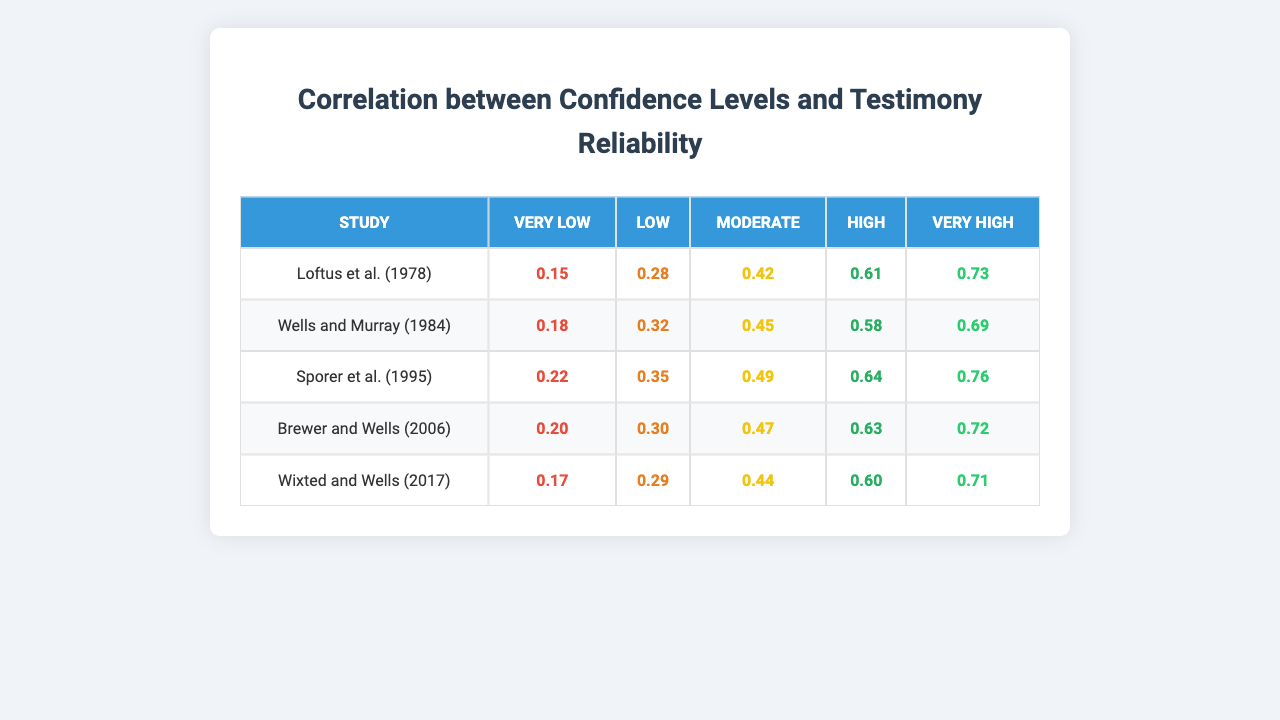What is the reliability score for the "Very High" confidence level in the study by Loftus et al. (1978)? Looking at the row for Loftus et al. (1978), the reliability score under the "Very High" confidence level is 0.73.
Answer: 0.73 Which study reported the highest reliability score for the "High" confidence level? By examining the scores for the "High" confidence level across all studies, the highest score is 0.76 from the study by Sporer et al. (1995).
Answer: Sporer et al. (1995) What is the average reliability score across all studies for the "Moderate" confidence level? The reliability scores for the "Moderate" level are 0.42, 0.45, 0.49, 0.47, and 0.44. Adding these scores gives 2.27, and dividing by 5 (the number of studies) results in an average of 0.454.
Answer: 0.454 Is the reliability score for the "Low" confidence level higher than that for the "Very Low" confidence level in the Brewer and Wells (2006) study? For Brewer and Wells (2006): Low confidence is 0.30 and Very Low is 0.20. Since 0.30 is greater than 0.20, the statement is true.
Answer: Yes What trend do you observe in the reliable scores as confidence levels increase across all studies? Each confidence level's reliability scores generally rise as levels go from Very Low to Very High, indicating a positive correlation between confidence and reliability for all studies presented.
Answer: Positive correlation Which confidence level shows the smallest reliability score in the Wixted and Wells (2017) study? Looking at the Wixted and Wells (2017) row, the smallest score is under the "Very Low" confidence level, which is 0.17.
Answer: Very Low What is the difference in reliability scores between the "High" and "Moderate" confidence levels in the study by Wells and Murray (1984)? For Wells and Murray (1984), the "High" confidence score is 0.58 and the "Moderate" level is 0.45. The difference is 0.58 - 0.45 = 0.13.
Answer: 0.13 How do the reliability scores for the "Very High" confidence level compare between Loftus et al. (1978) and Brewer and Wells (2006)? In Loftus et al. (1978), the "Very High" score is 0.73, and in Brewer and Wells (2006), it is 0.72. The difference is minimal, showing that both studies have similar scores at this confidence level.
Answer: Similar scores What is the overall trend in reliability scores from Very Low to Very High across all studies? The overall trend shows that reliability scores increase from Very Low to Very High across all studies, indicating that as witness confidence increases, reliability tends to improve.
Answer: Increasing trend Which study's reliability scores for "Moderate" confidence levels are closest to the average of the scores for this level across all studies? Computing the average moderate score as 0.454, Brewer and Wells (2006) with a score of 0.47 is the closest to the average among the studies listed.
Answer: Brewer and Wells (2006) 